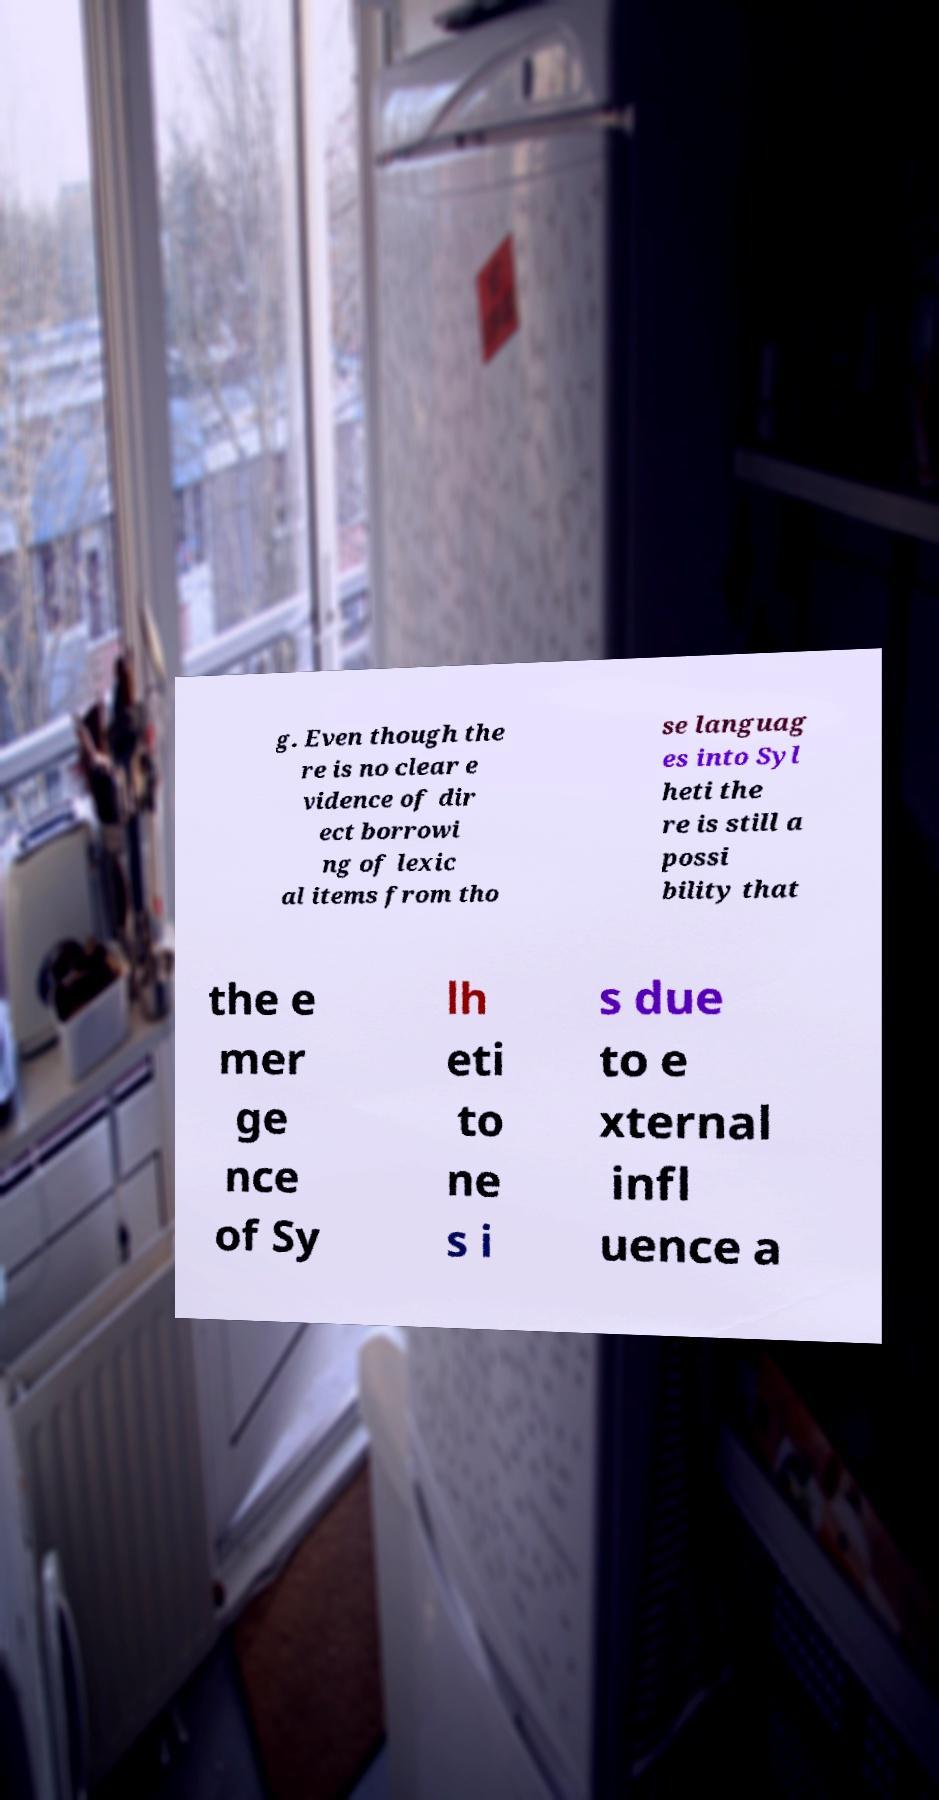I need the written content from this picture converted into text. Can you do that? g. Even though the re is no clear e vidence of dir ect borrowi ng of lexic al items from tho se languag es into Syl heti the re is still a possi bility that the e mer ge nce of Sy lh eti to ne s i s due to e xternal infl uence a 